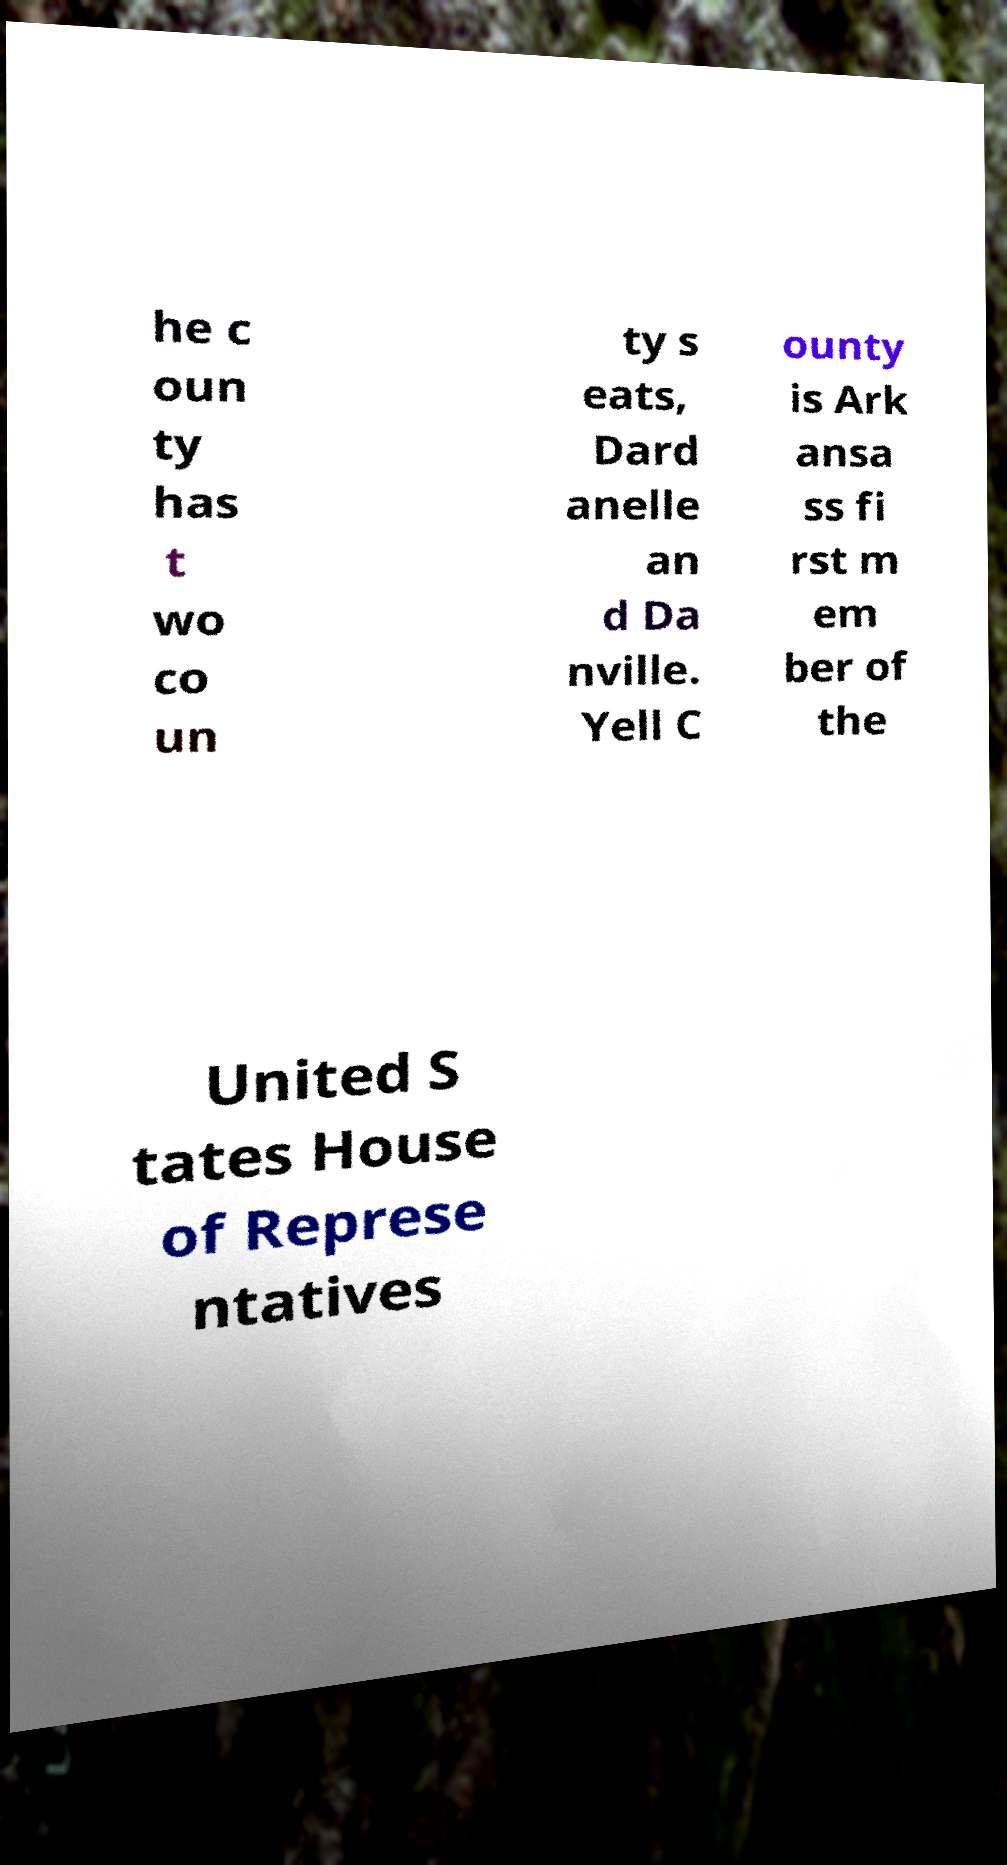Please read and relay the text visible in this image. What does it say? he c oun ty has t wo co un ty s eats, Dard anelle an d Da nville. Yell C ounty is Ark ansa ss fi rst m em ber of the United S tates House of Represe ntatives 